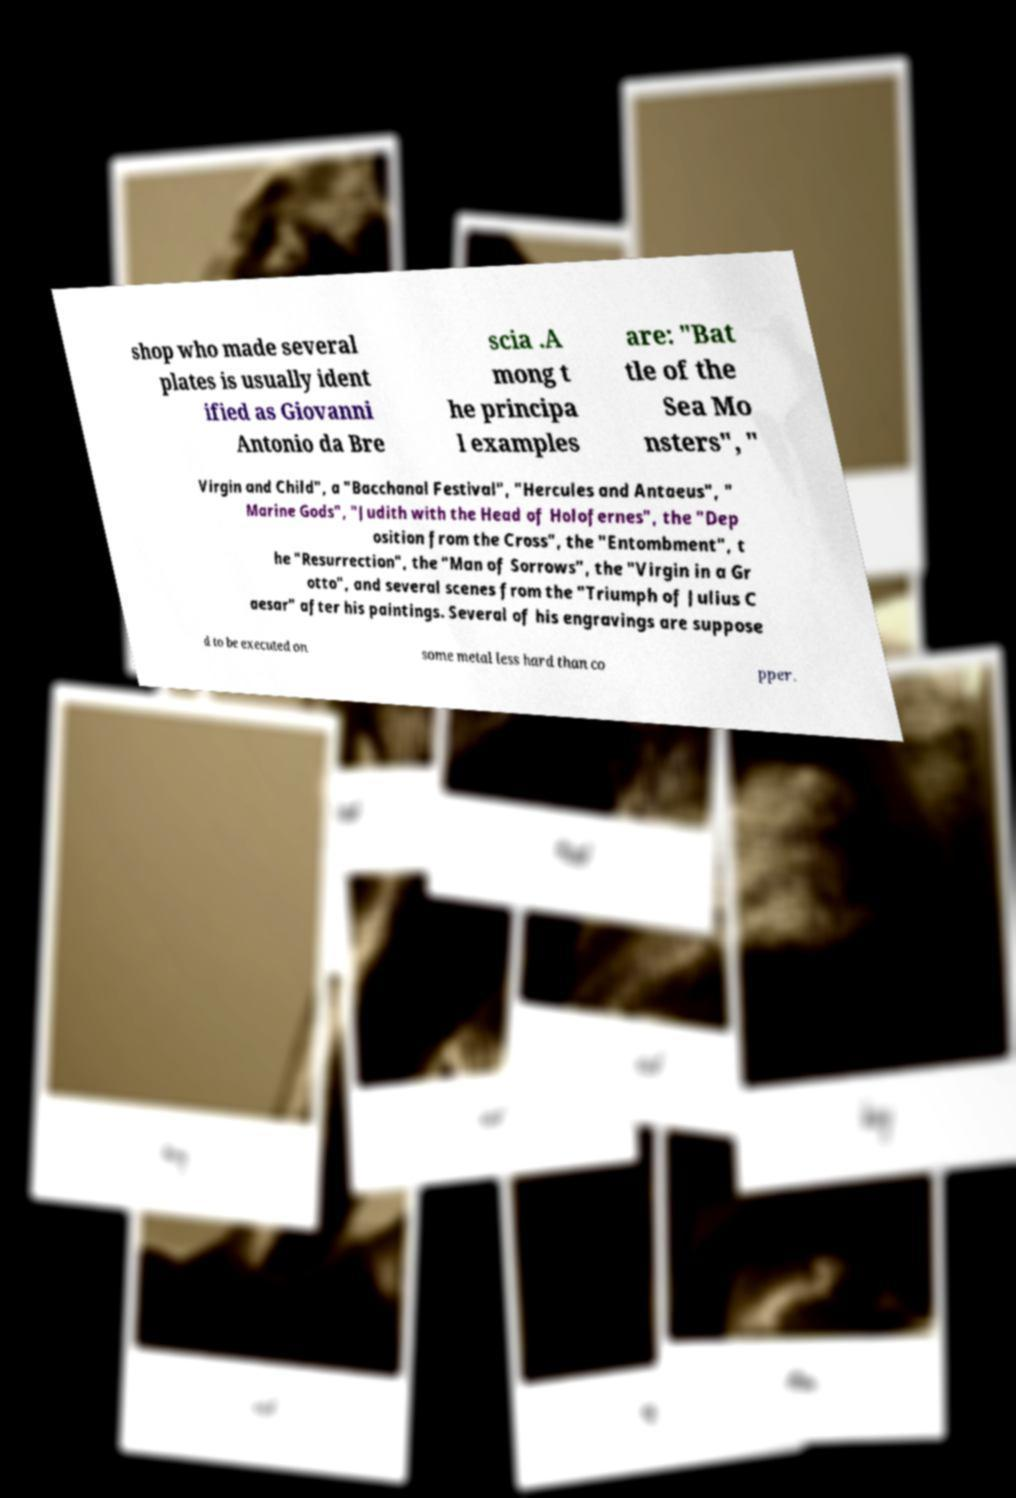Could you extract and type out the text from this image? shop who made several plates is usually ident ified as Giovanni Antonio da Bre scia .A mong t he principa l examples are: "Bat tle of the Sea Mo nsters", " Virgin and Child", a "Bacchanal Festival", "Hercules and Antaeus", " Marine Gods", "Judith with the Head of Holofernes", the "Dep osition from the Cross", the "Entombment", t he "Resurrection", the "Man of Sorrows", the "Virgin in a Gr otto", and several scenes from the "Triumph of Julius C aesar" after his paintings. Several of his engravings are suppose d to be executed on some metal less hard than co pper. 